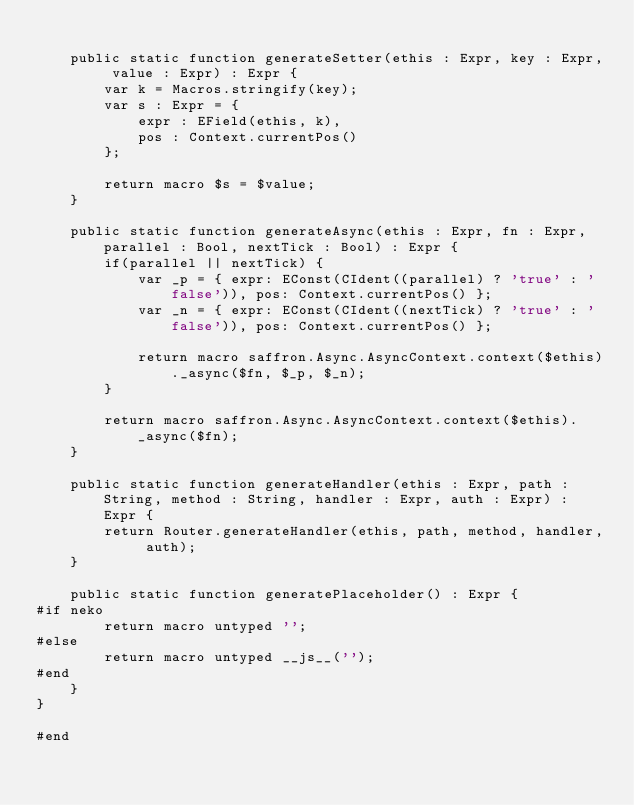Convert code to text. <code><loc_0><loc_0><loc_500><loc_500><_Haxe_>    
    public static function generateSetter(ethis : Expr, key : Expr, value : Expr) : Expr {	
        var k = Macros.stringify(key);
        var s : Expr = {
            expr : EField(ethis, k), 
            pos : Context.currentPos()
        };
        
        return macro $s = $value;
    }
    
    public static function generateAsync(ethis : Expr, fn : Expr, parallel : Bool, nextTick : Bool) : Expr {
        if(parallel || nextTick) {
            var _p = { expr: EConst(CIdent((parallel) ? 'true' : 'false')), pos: Context.currentPos() };
            var _n = { expr: EConst(CIdent((nextTick) ? 'true' : 'false')), pos: Context.currentPos() };
            
            return macro saffron.Async.AsyncContext.context($ethis)._async($fn, $_p, $_n);
        }
        
        return macro saffron.Async.AsyncContext.context($ethis)._async($fn);
    }
    
    public static function generateHandler(ethis : Expr, path : String, method : String, handler : Expr, auth : Expr) : Expr {
        return Router.generateHandler(ethis, path, method, handler, auth);
    }
    
    public static function generatePlaceholder() : Expr {
#if neko
        return macro untyped '';
#else
        return macro untyped __js__('');
#end
    }
}

#end
</code> 